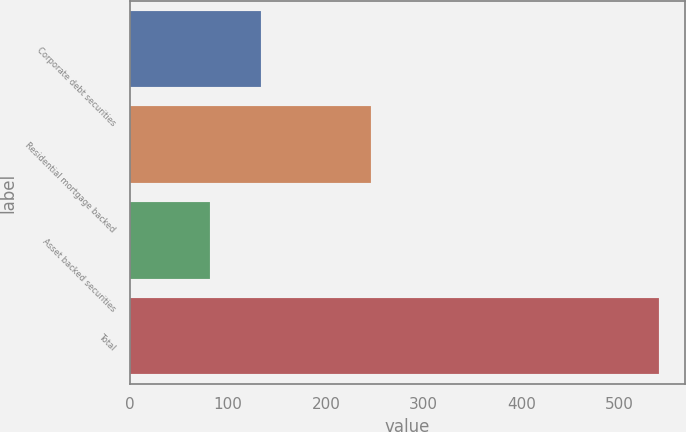<chart> <loc_0><loc_0><loc_500><loc_500><bar_chart><fcel>Corporate debt securities<fcel>Residential mortgage backed<fcel>Asset backed securities<fcel>Total<nl><fcel>134<fcel>246<fcel>82<fcel>540<nl></chart> 